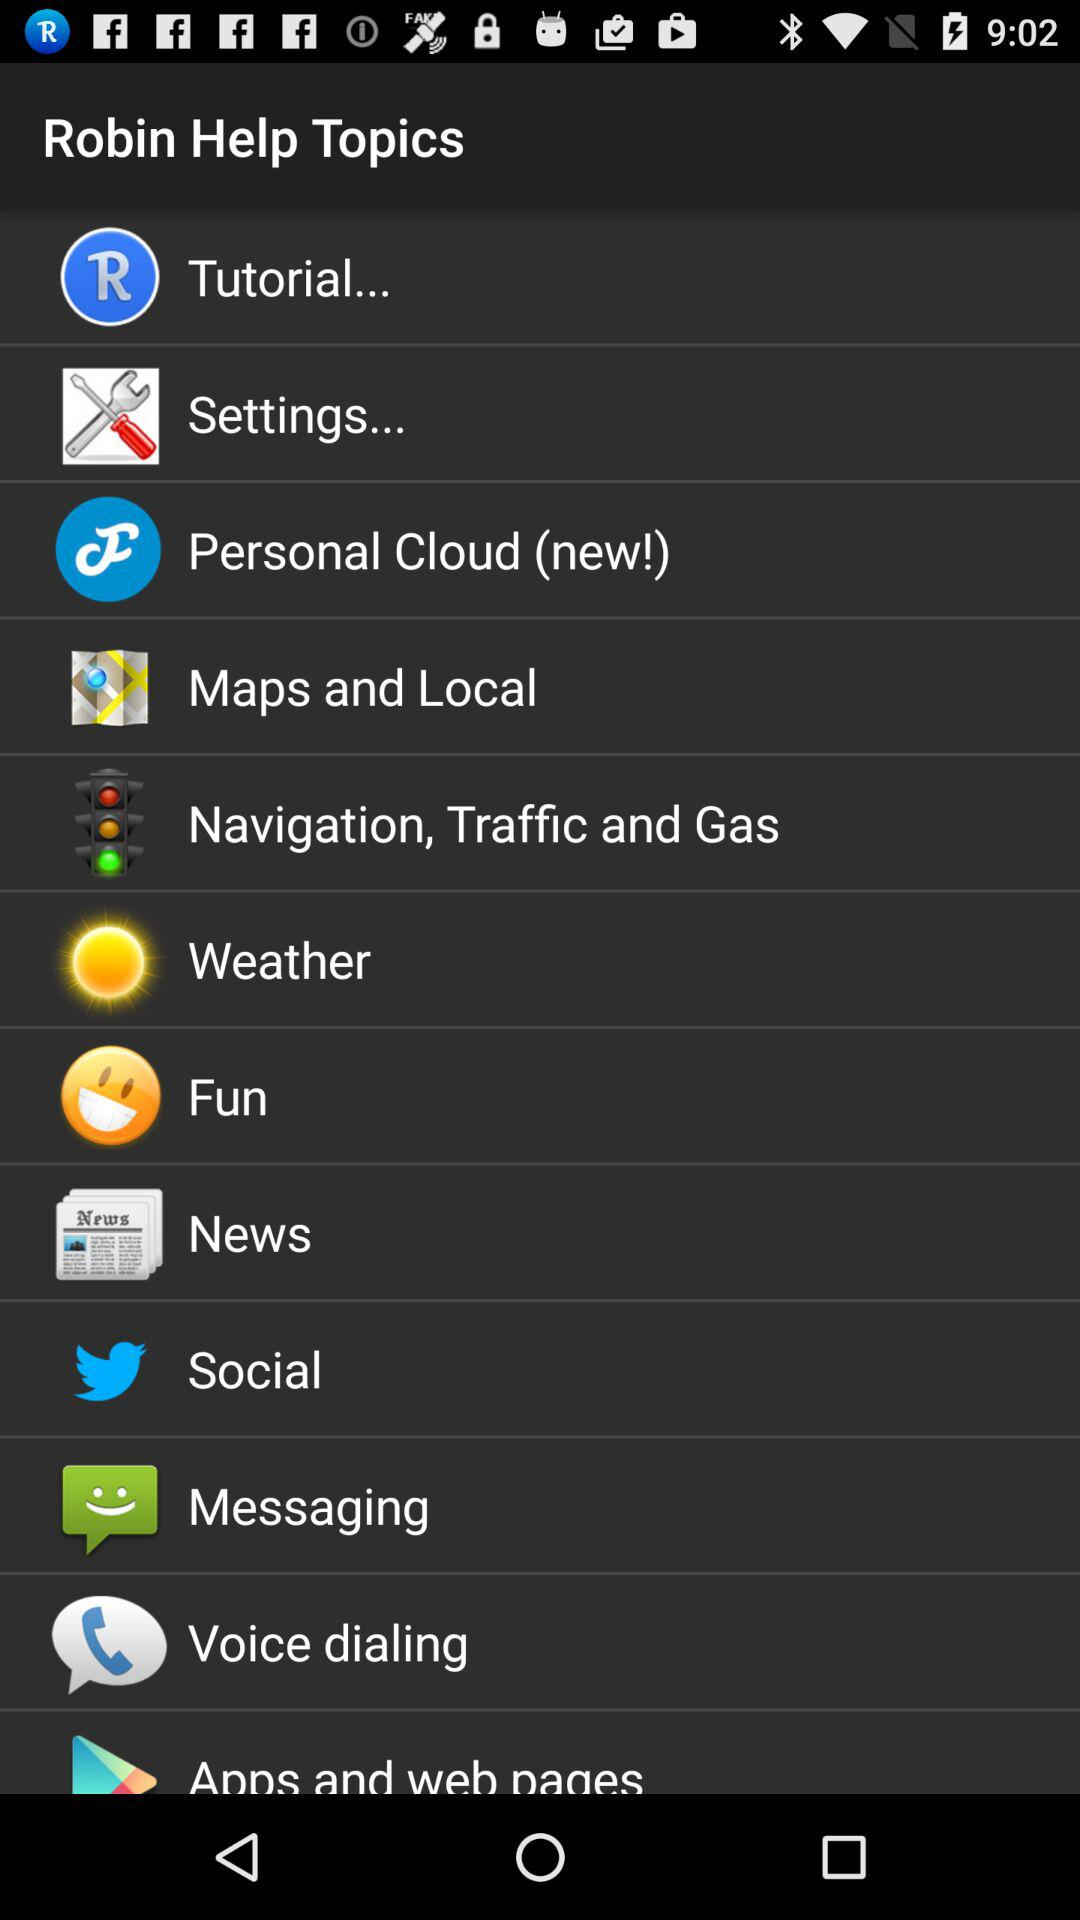What topic is new? The new topic is "Personal Cloud". 